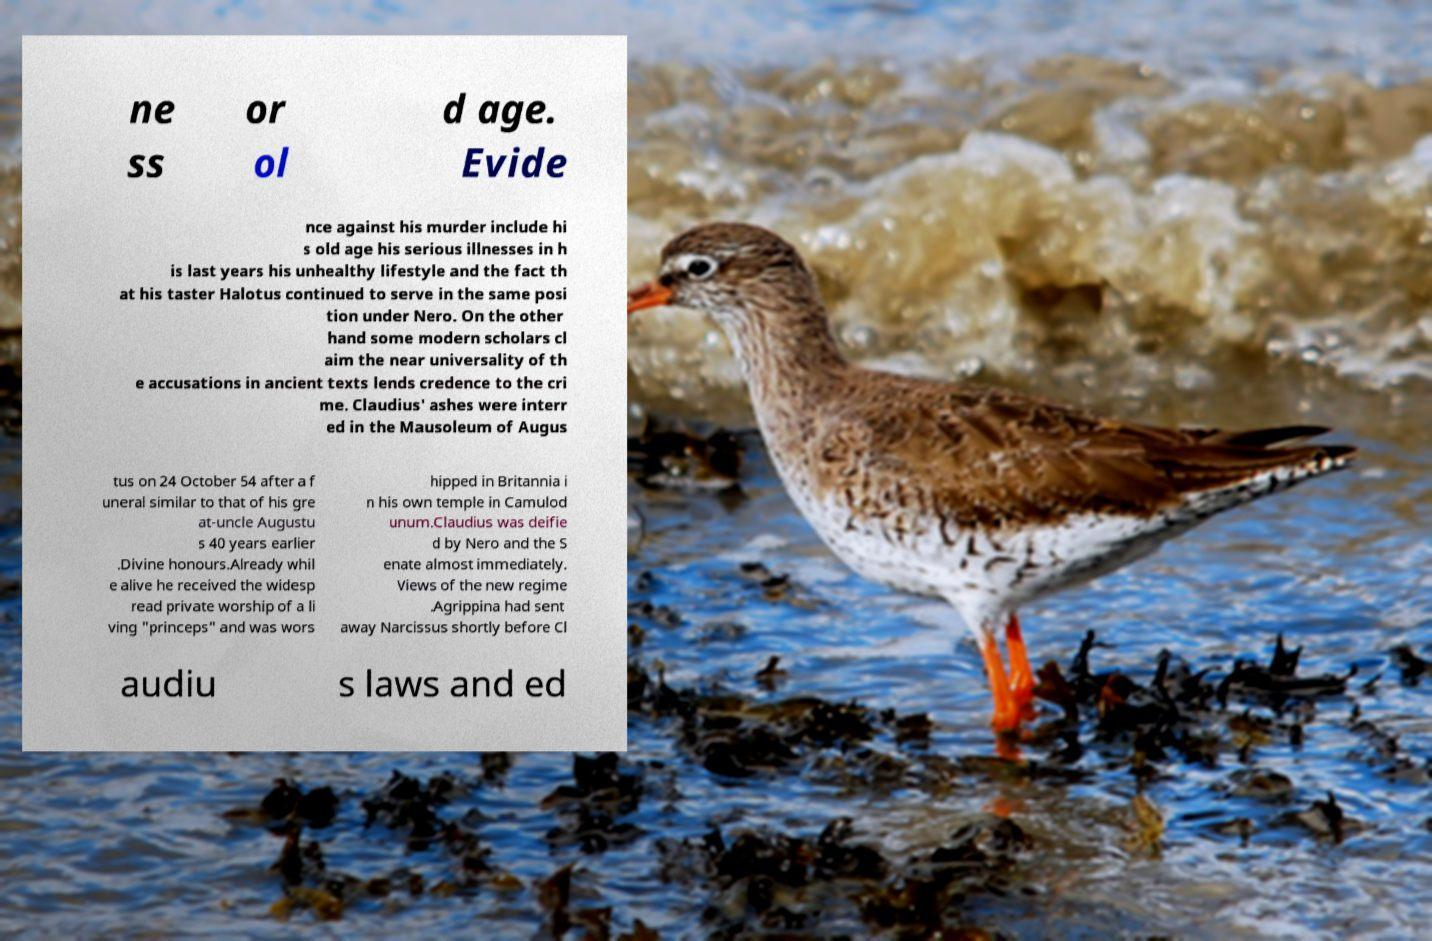I need the written content from this picture converted into text. Can you do that? ne ss or ol d age. Evide nce against his murder include hi s old age his serious illnesses in h is last years his unhealthy lifestyle and the fact th at his taster Halotus continued to serve in the same posi tion under Nero. On the other hand some modern scholars cl aim the near universality of th e accusations in ancient texts lends credence to the cri me. Claudius' ashes were interr ed in the Mausoleum of Augus tus on 24 October 54 after a f uneral similar to that of his gre at-uncle Augustu s 40 years earlier .Divine honours.Already whil e alive he received the widesp read private worship of a li ving "princeps" and was wors hipped in Britannia i n his own temple in Camulod unum.Claudius was deifie d by Nero and the S enate almost immediately. Views of the new regime .Agrippina had sent away Narcissus shortly before Cl audiu s laws and ed 